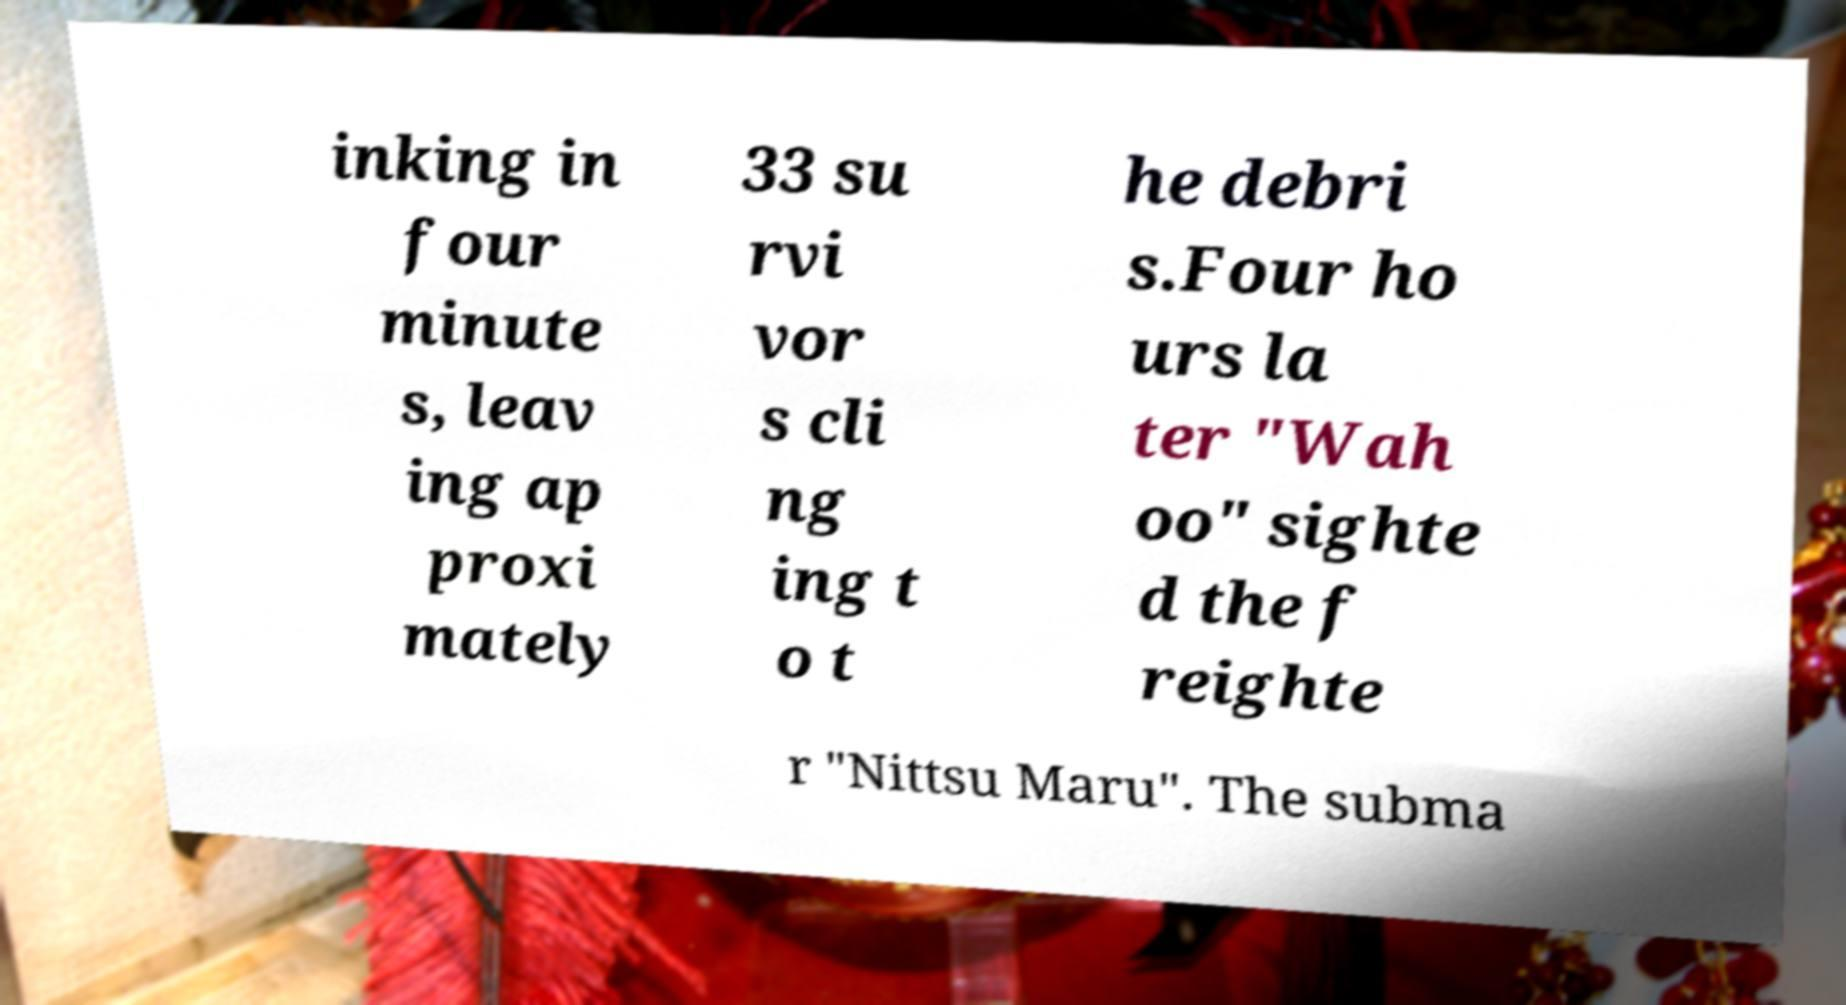Can you accurately transcribe the text from the provided image for me? inking in four minute s, leav ing ap proxi mately 33 su rvi vor s cli ng ing t o t he debri s.Four ho urs la ter "Wah oo" sighte d the f reighte r "Nittsu Maru". The subma 